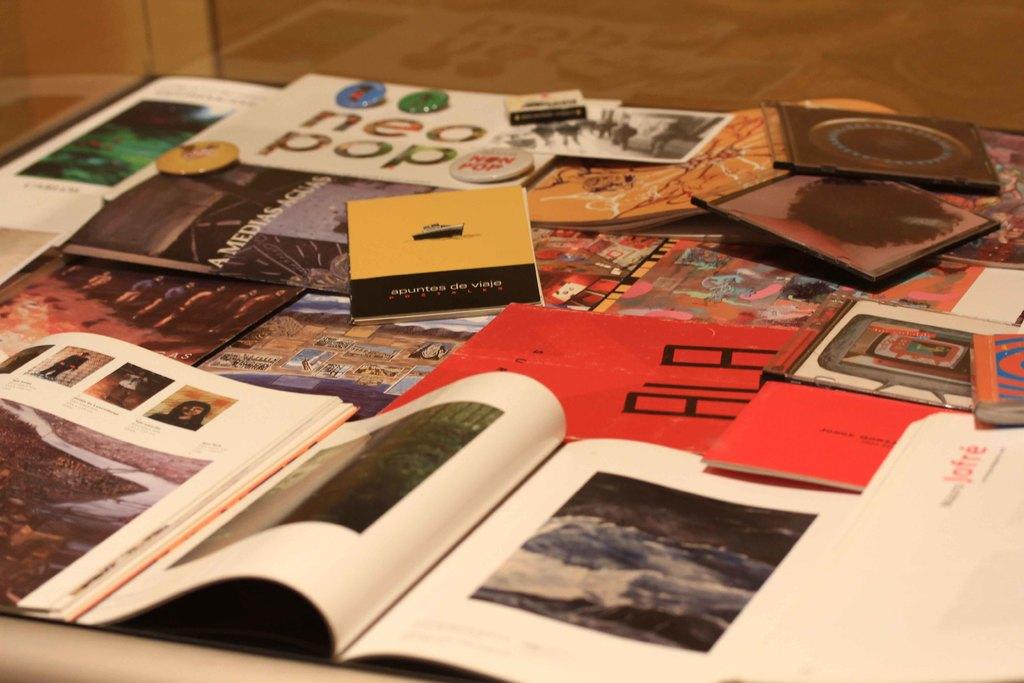What kind of pop?
Your answer should be compact. Neo. 